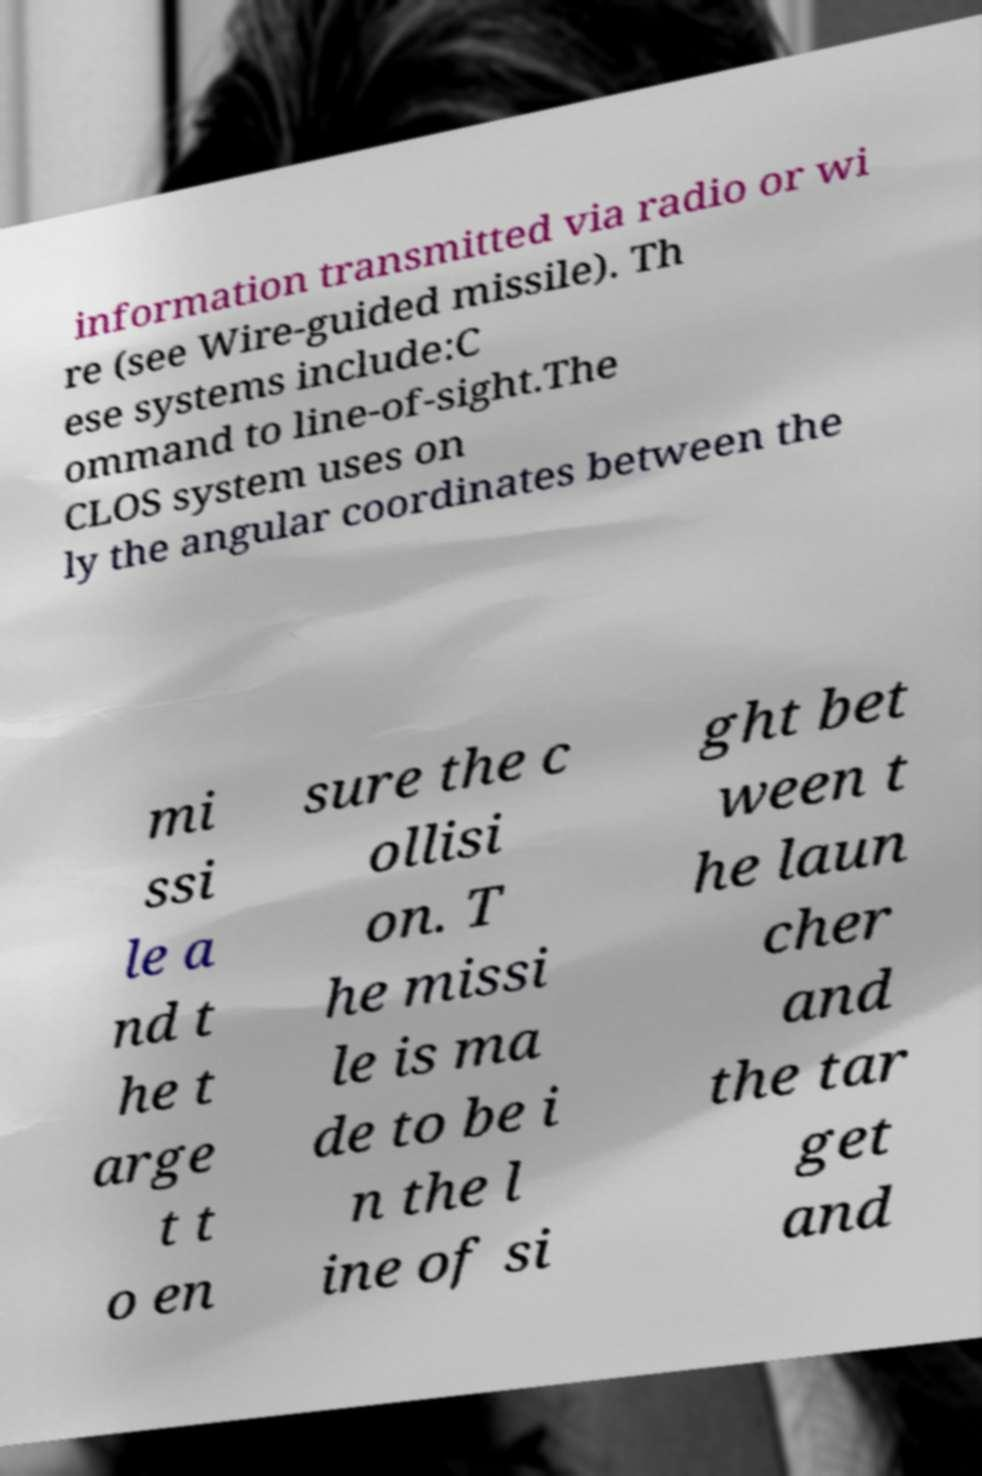Can you accurately transcribe the text from the provided image for me? information transmitted via radio or wi re (see Wire-guided missile). Th ese systems include:C ommand to line-of-sight.The CLOS system uses on ly the angular coordinates between the mi ssi le a nd t he t arge t t o en sure the c ollisi on. T he missi le is ma de to be i n the l ine of si ght bet ween t he laun cher and the tar get and 